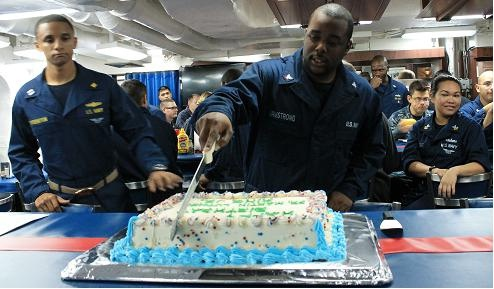Describe the objects in this image and their specific colors. I can see people in lightgray, black, gray, blue, and navy tones, dining table in lightgray, gray, darkgray, and blue tones, people in lightgray, black, navy, gray, and darkblue tones, cake in lightgray, beige, darkgray, and lightblue tones, and people in lightgray, black, tan, and gray tones in this image. 